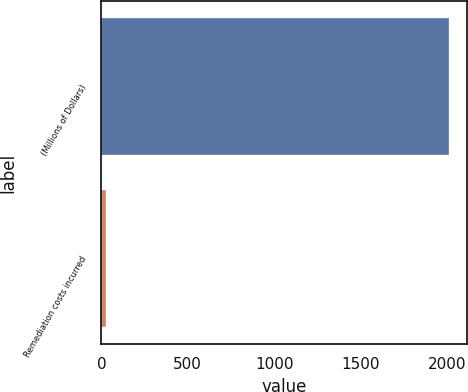Convert chart. <chart><loc_0><loc_0><loc_500><loc_500><bar_chart><fcel>(Millions of Dollars)<fcel>Remediation costs incurred<nl><fcel>2014<fcel>29<nl></chart> 